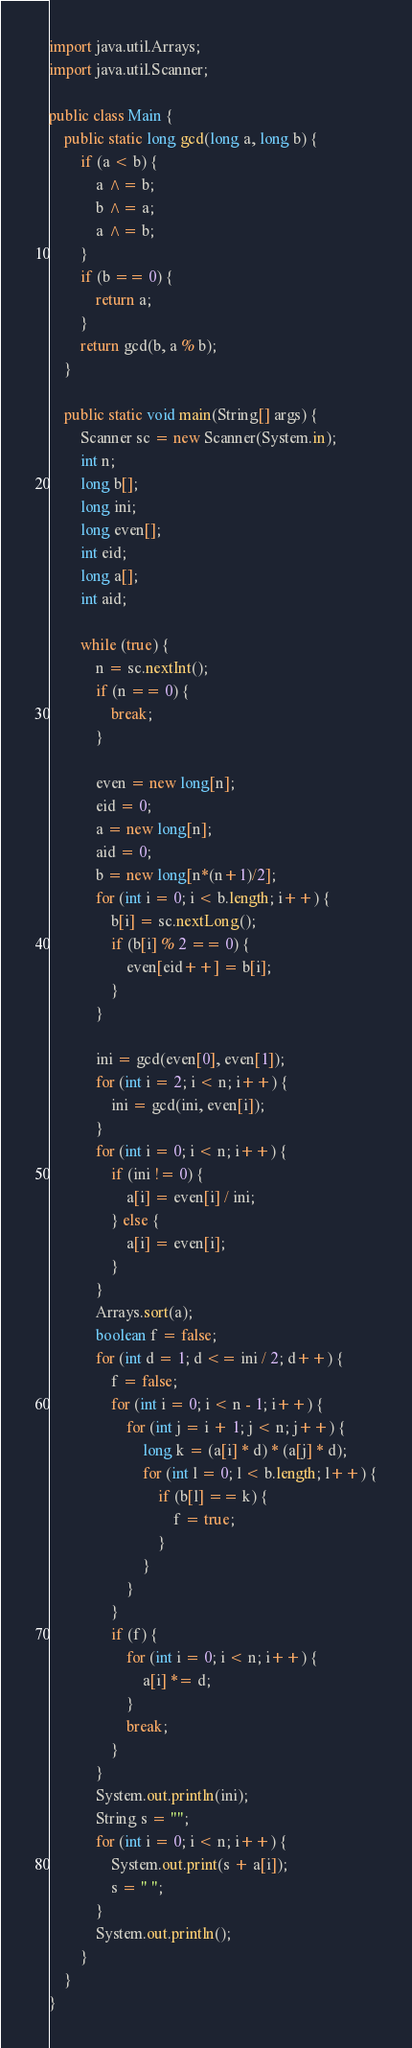Convert code to text. <code><loc_0><loc_0><loc_500><loc_500><_Java_>import java.util.Arrays;
import java.util.Scanner;

public class Main {
	public static long gcd(long a, long b) {
		if (a < b) {
			a ^= b;
			b ^= a;
			a ^= b;
		}
		if (b == 0) {
			return a;
		}
		return gcd(b, a % b);
	}

	public static void main(String[] args) {
		Scanner sc = new Scanner(System.in);
		int n;
		long b[];
		long ini;
		long even[];
		int eid;
		long a[];
		int aid;

		while (true) {
			n = sc.nextInt();
			if (n == 0) {
				break;
			}

			even = new long[n];
			eid = 0;
			a = new long[n];
			aid = 0;
			b = new long[n*(n+1)/2];
			for (int i = 0; i < b.length; i++) {
				b[i] = sc.nextLong();
				if (b[i] % 2 == 0) {
					even[eid++] = b[i];
				}
			}

			ini = gcd(even[0], even[1]);
			for (int i = 2; i < n; i++) {
				ini = gcd(ini, even[i]);
			}
			for (int i = 0; i < n; i++) {
				if (ini != 0) {
					a[i] = even[i] / ini;
				} else {
					a[i] = even[i];
				}
			}
			Arrays.sort(a);
			boolean f = false;
			for (int d = 1; d <= ini / 2; d++) {
				f = false;
				for (int i = 0; i < n - 1; i++) {
					for (int j = i + 1; j < n; j++) {
						long k = (a[i] * d) * (a[j] * d);
						for (int l = 0; l < b.length; l++) {
							if (b[l] == k) {
								f = true;
							}
						}
					}
				}
				if (f) {
					for (int i = 0; i < n; i++) {
						a[i] *= d;
					}
					break;
				}
			}
			System.out.println(ini);
			String s = "";
			for (int i = 0; i < n; i++) {
				System.out.print(s + a[i]);
				s = " ";
			}
			System.out.println();
		}
	}
}</code> 